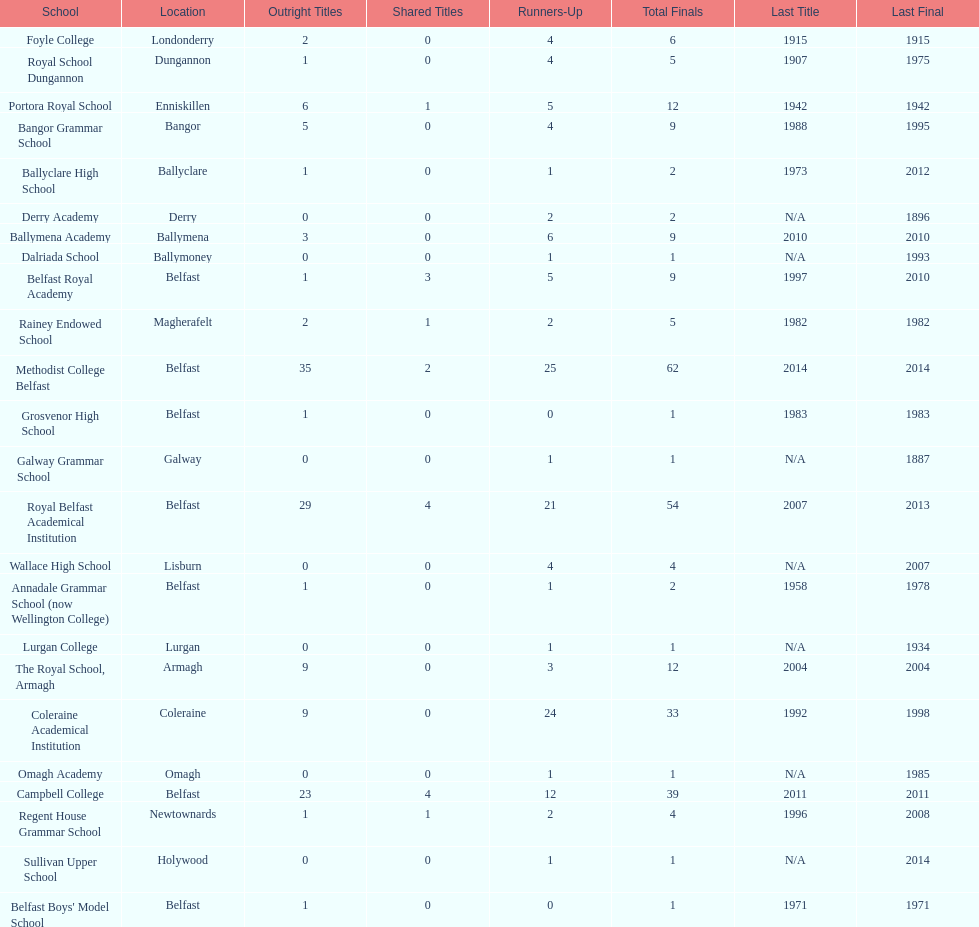Did belfast royal academy participate in a greater or lesser number of total finals compared to ballyclare high school? More. Would you mind parsing the complete table? {'header': ['School', 'Location', 'Outright Titles', 'Shared Titles', 'Runners-Up', 'Total Finals', 'Last Title', 'Last Final'], 'rows': [['Foyle College', 'Londonderry', '2', '0', '4', '6', '1915', '1915'], ['Royal School Dungannon', 'Dungannon', '1', '0', '4', '5', '1907', '1975'], ['Portora Royal School', 'Enniskillen', '6', '1', '5', '12', '1942', '1942'], ['Bangor Grammar School', 'Bangor', '5', '0', '4', '9', '1988', '1995'], ['Ballyclare High School', 'Ballyclare', '1', '0', '1', '2', '1973', '2012'], ['Derry Academy', 'Derry', '0', '0', '2', '2', 'N/A', '1896'], ['Ballymena Academy', 'Ballymena', '3', '0', '6', '9', '2010', '2010'], ['Dalriada School', 'Ballymoney', '0', '0', '1', '1', 'N/A', '1993'], ['Belfast Royal Academy', 'Belfast', '1', '3', '5', '9', '1997', '2010'], ['Rainey Endowed School', 'Magherafelt', '2', '1', '2', '5', '1982', '1982'], ['Methodist College Belfast', 'Belfast', '35', '2', '25', '62', '2014', '2014'], ['Grosvenor High School', 'Belfast', '1', '0', '0', '1', '1983', '1983'], ['Galway Grammar School', 'Galway', '0', '0', '1', '1', 'N/A', '1887'], ['Royal Belfast Academical Institution', 'Belfast', '29', '4', '21', '54', '2007', '2013'], ['Wallace High School', 'Lisburn', '0', '0', '4', '4', 'N/A', '2007'], ['Annadale Grammar School (now Wellington College)', 'Belfast', '1', '0', '1', '2', '1958', '1978'], ['Lurgan College', 'Lurgan', '0', '0', '1', '1', 'N/A', '1934'], ['The Royal School, Armagh', 'Armagh', '9', '0', '3', '12', '2004', '2004'], ['Coleraine Academical Institution', 'Coleraine', '9', '0', '24', '33', '1992', '1998'], ['Omagh Academy', 'Omagh', '0', '0', '1', '1', 'N/A', '1985'], ['Campbell College', 'Belfast', '23', '4', '12', '39', '2011', '2011'], ['Regent House Grammar School', 'Newtownards', '1', '1', '2', '4', '1996', '2008'], ['Sullivan Upper School', 'Holywood', '0', '0', '1', '1', 'N/A', '2014'], ["Belfast Boys' Model School", 'Belfast', '1', '0', '0', '1', '1971', '1971']]} 